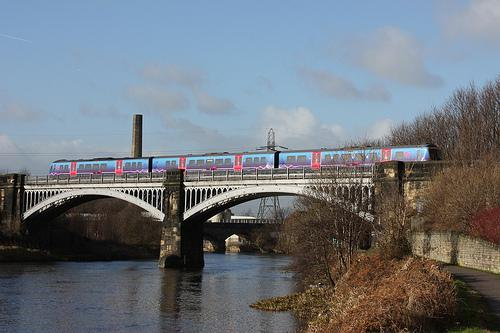Question: when the picture taken?
Choices:
A. During the day.
B. At dawn.
C. At dusk.
D. At night.
Answer with the letter. Answer: A Question: what color is the train?
Choices:
A. Yellow, green, and red.
B. Blue, purple and red.
C. Green, blue and white.
D. Black, red, and blue.
Answer with the letter. Answer: B Question: what is crossing the bridge?
Choices:
A. A train.
B. A person.
C. A dog.
D. A bike.
Answer with the letter. Answer: A Question: how many trains are in the image?
Choices:
A. One.
B. Two.
C. Three.
D. Four.
Answer with the letter. Answer: A Question: where is the train?
Choices:
A. In the town.
B. At the train stop.
C. In the field.
D. On the bridge.
Answer with the letter. Answer: D 